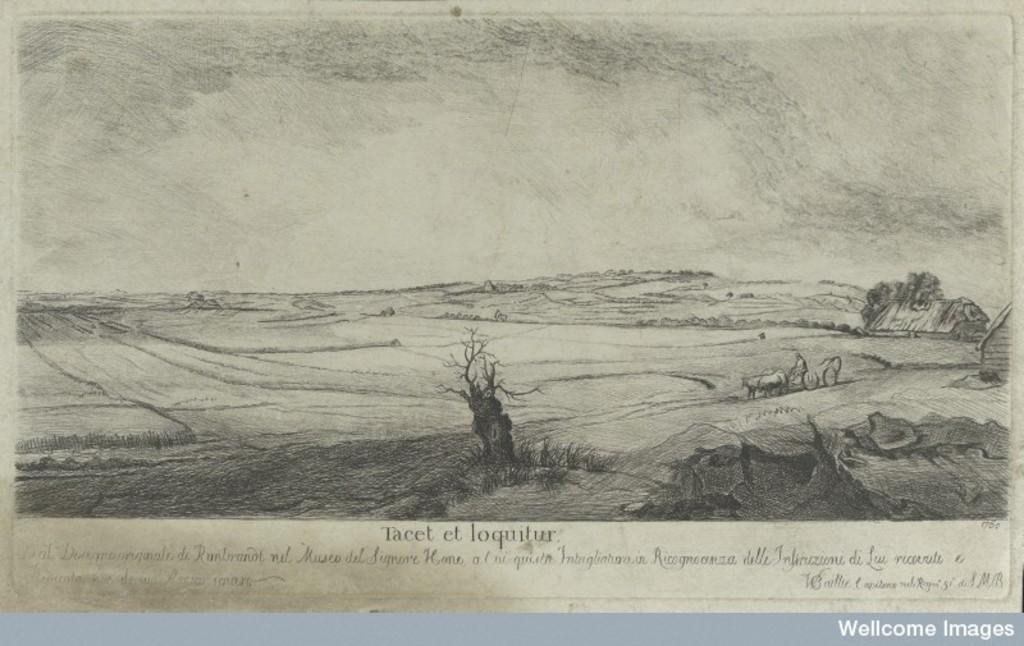What is depicted on the paper in the image? The paper contains a drawing of dried trees, a bullock cart, and a house. Are there any other elements on the paper besides the drawings? Yes, there is writing on the paper. What type of toys can be seen in the image? There are no toys present in the image; it features a paper with drawings and writing. What kind of silk material is used in the drawing of the house? There is no silk material mentioned or depicted in the drawing of the house; it is a simple drawing on paper. 